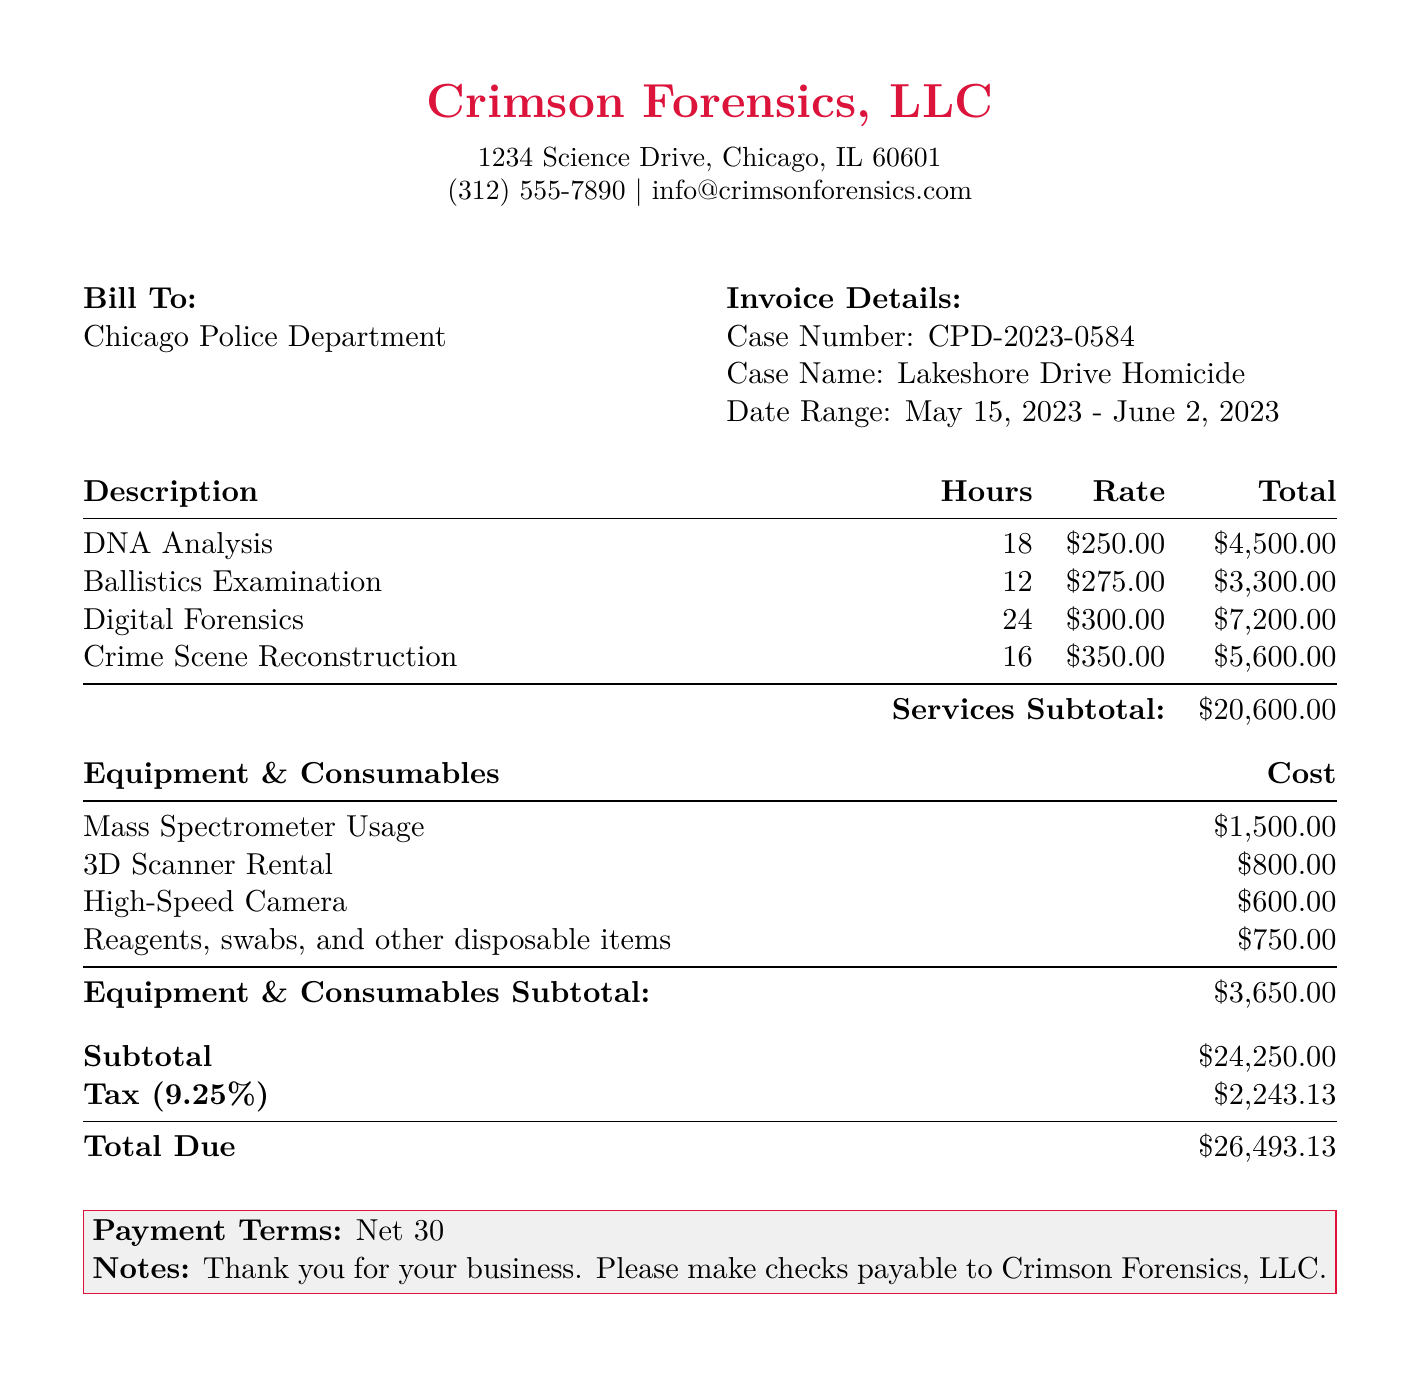what is the total due amount? The total due amount is listed in the final section of the invoice as the overall cost after subtotal and taxes.
Answer: $26,493.13 what is the date range for the services provided? The date range is specified in the invoice details section as the period during which the services were rendered.
Answer: May 15, 2023 - June 2, 2023 who is the billing recipient? The billing recipient is identified at the top of the bill, indicating whom the services are billed to.
Answer: Chicago Police Department how many hours were spent on Digital Forensics? The hours spent on Digital Forensics are detailed in the table of services, showing the allocation of time for specific tasks.
Answer: 24 what is the subtotal for the services provided? The subtotal for services is calculated from the sum of all individual service costs before tax.
Answer: $20,600.00 what percentage is the tax on the invoice? The tax percentage is indicated in the financial summary section of the bill, which applies to the subtotal amount.
Answer: 9.25% what is the cost of the Mass Spectrometer usage? The cost for using the Mass Spectrometer is found in the equipment and consumables section and specifies the charge associated with it.
Answer: $1,500.00 what are the payment terms specified in the document? The payment terms outline the conditions for payment in the final remarks of the invoice.
Answer: Net 30 